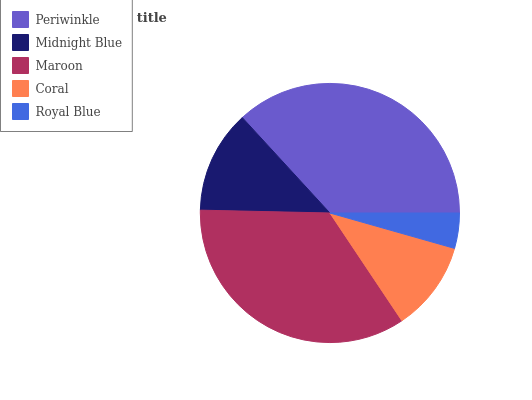Is Royal Blue the minimum?
Answer yes or no. Yes. Is Periwinkle the maximum?
Answer yes or no. Yes. Is Midnight Blue the minimum?
Answer yes or no. No. Is Midnight Blue the maximum?
Answer yes or no. No. Is Periwinkle greater than Midnight Blue?
Answer yes or no. Yes. Is Midnight Blue less than Periwinkle?
Answer yes or no. Yes. Is Midnight Blue greater than Periwinkle?
Answer yes or no. No. Is Periwinkle less than Midnight Blue?
Answer yes or no. No. Is Midnight Blue the high median?
Answer yes or no. Yes. Is Midnight Blue the low median?
Answer yes or no. Yes. Is Royal Blue the high median?
Answer yes or no. No. Is Royal Blue the low median?
Answer yes or no. No. 